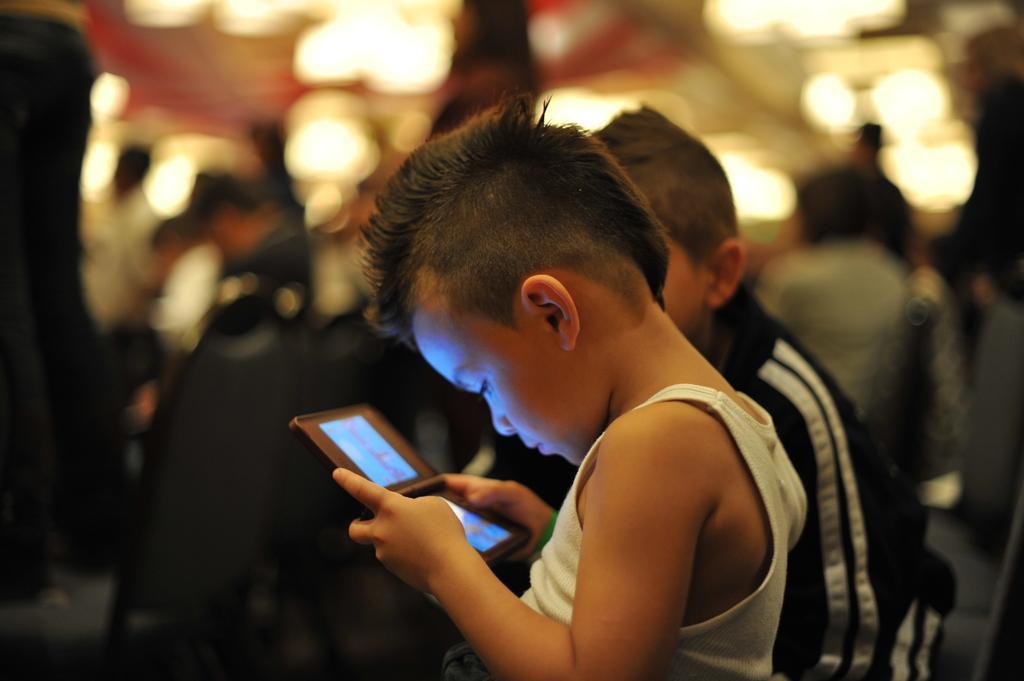In one or two sentences, can you explain what this image depicts? In the image there is a boy playing on tablet and beside him there is another boy and in background there are lights and many people. 